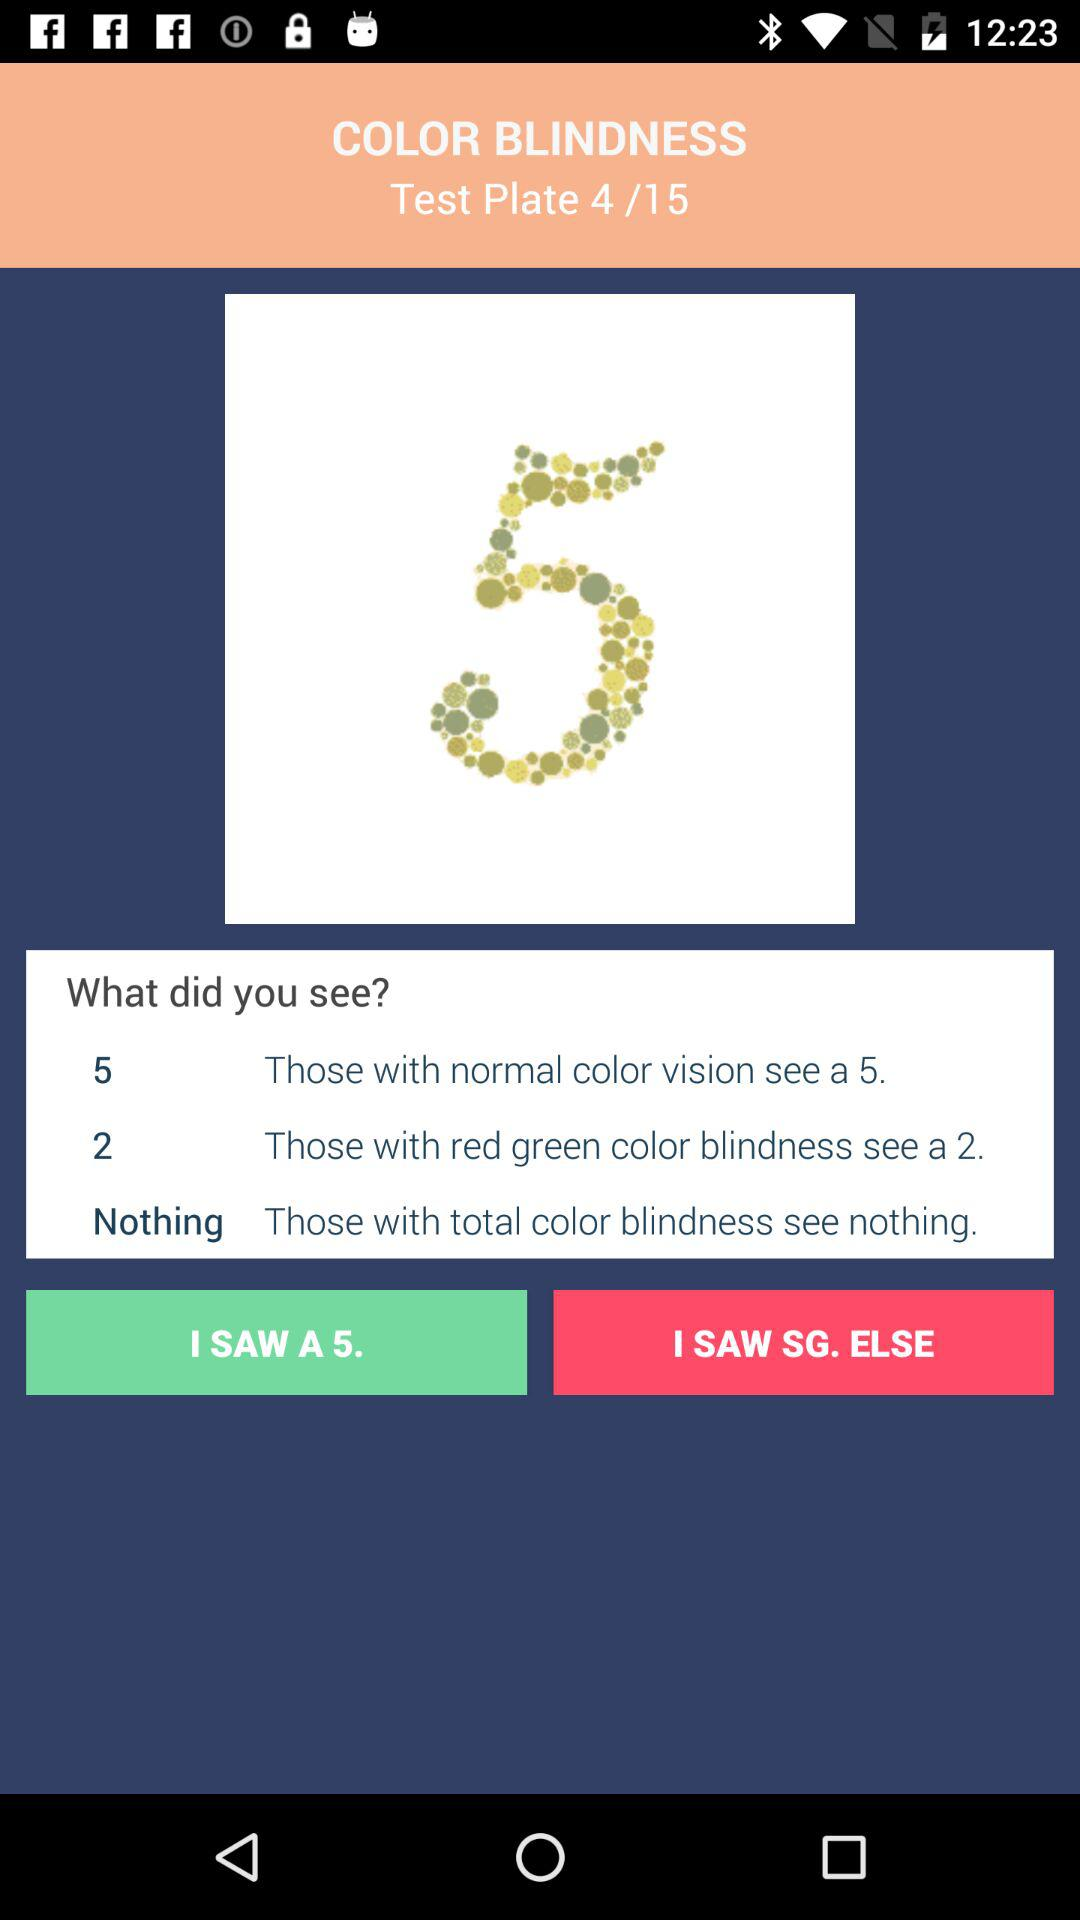What does a person with total color blindness see? A person with total color blindness sees nothing. 